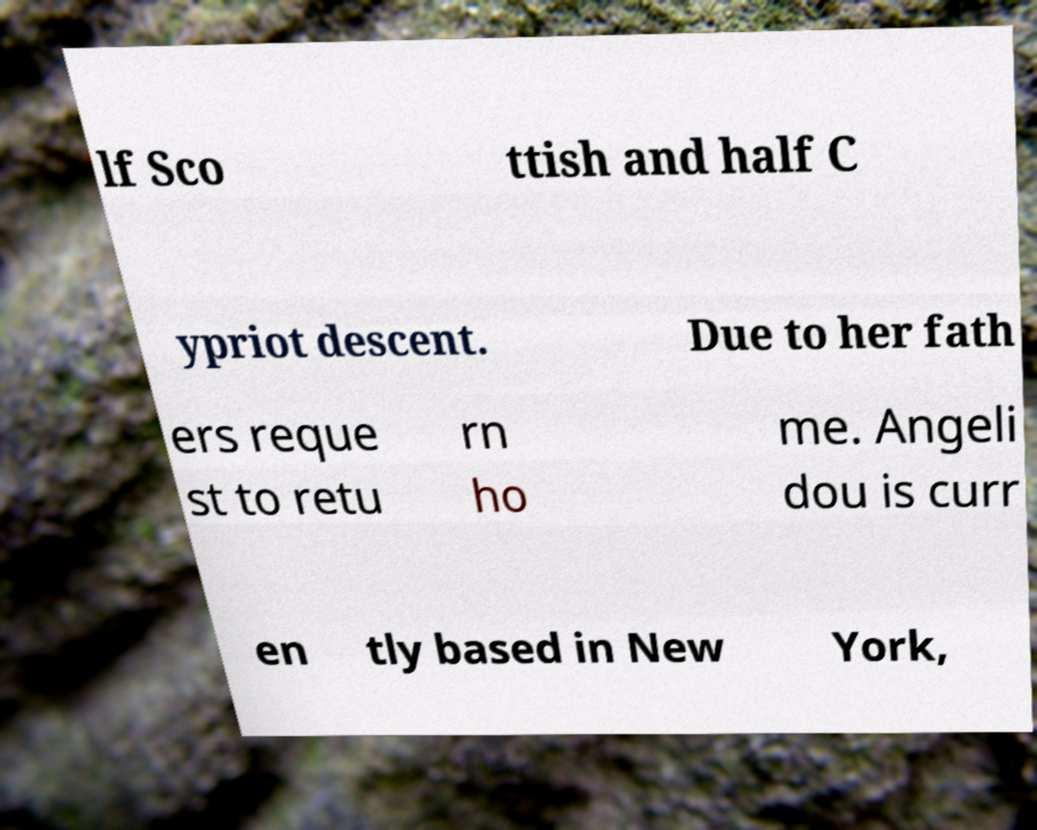Please identify and transcribe the text found in this image. lf Sco ttish and half C ypriot descent. Due to her fath ers reque st to retu rn ho me. Angeli dou is curr en tly based in New York, 